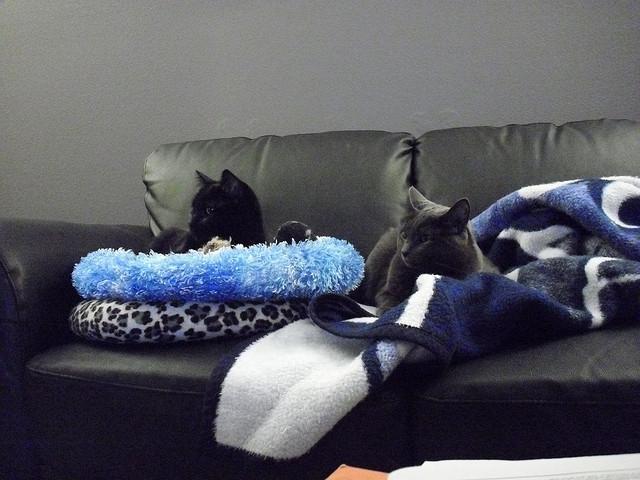How many cats are in the photo?
Give a very brief answer. 2. 